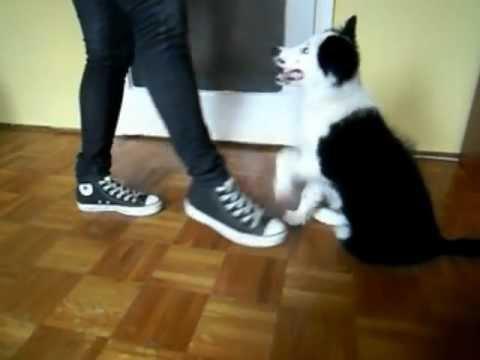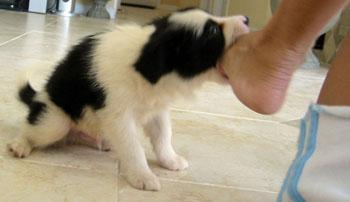The first image is the image on the left, the second image is the image on the right. Evaluate the accuracy of this statement regarding the images: "In one of the images there is a black and white dog lying on the floor.". Is it true? Answer yes or no. No. The first image is the image on the left, the second image is the image on the right. Analyze the images presented: Is the assertion "At least one image includes a person in jeans next to a dog, and each image includes a dog that is sitting." valid? Answer yes or no. Yes. 